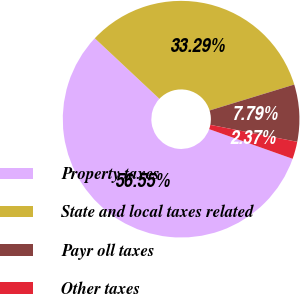Convert chart. <chart><loc_0><loc_0><loc_500><loc_500><pie_chart><fcel>Property taxes<fcel>State and local taxes related<fcel>Payr oll taxes<fcel>Other taxes<nl><fcel>56.55%<fcel>33.29%<fcel>7.79%<fcel>2.37%<nl></chart> 